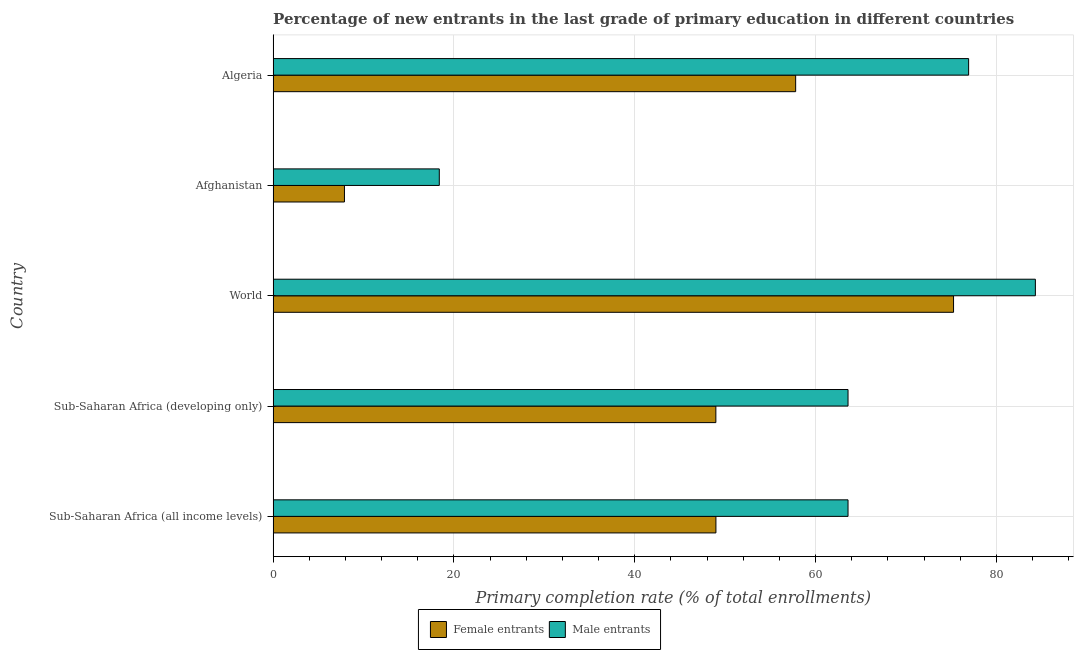How many groups of bars are there?
Offer a very short reply. 5. Are the number of bars on each tick of the Y-axis equal?
Offer a terse response. Yes. How many bars are there on the 3rd tick from the top?
Offer a terse response. 2. What is the label of the 1st group of bars from the top?
Your response must be concise. Algeria. In how many cases, is the number of bars for a given country not equal to the number of legend labels?
Offer a terse response. 0. What is the primary completion rate of female entrants in Algeria?
Offer a very short reply. 57.79. Across all countries, what is the maximum primary completion rate of male entrants?
Keep it short and to the point. 84.3. Across all countries, what is the minimum primary completion rate of female entrants?
Provide a short and direct response. 7.89. In which country was the primary completion rate of male entrants minimum?
Keep it short and to the point. Afghanistan. What is the total primary completion rate of male entrants in the graph?
Make the answer very short. 306.77. What is the difference between the primary completion rate of male entrants in Afghanistan and that in Sub-Saharan Africa (developing only)?
Your answer should be very brief. -45.2. What is the difference between the primary completion rate of female entrants in World and the primary completion rate of male entrants in Afghanistan?
Keep it short and to the point. 56.87. What is the average primary completion rate of female entrants per country?
Your answer should be compact. 47.77. What is the difference between the primary completion rate of male entrants and primary completion rate of female entrants in World?
Make the answer very short. 9.05. In how many countries, is the primary completion rate of male entrants greater than 60 %?
Offer a very short reply. 4. What is the ratio of the primary completion rate of female entrants in Algeria to that in Sub-Saharan Africa (developing only)?
Offer a very short reply. 1.18. What is the difference between the highest and the second highest primary completion rate of female entrants?
Your response must be concise. 17.46. What is the difference between the highest and the lowest primary completion rate of male entrants?
Give a very brief answer. 65.92. In how many countries, is the primary completion rate of male entrants greater than the average primary completion rate of male entrants taken over all countries?
Offer a terse response. 4. What does the 2nd bar from the top in Sub-Saharan Africa (all income levels) represents?
Ensure brevity in your answer.  Female entrants. What does the 1st bar from the bottom in Afghanistan represents?
Give a very brief answer. Female entrants. How many bars are there?
Provide a short and direct response. 10. What is the difference between two consecutive major ticks on the X-axis?
Your answer should be very brief. 20. Does the graph contain grids?
Offer a terse response. Yes. How are the legend labels stacked?
Your response must be concise. Horizontal. What is the title of the graph?
Give a very brief answer. Percentage of new entrants in the last grade of primary education in different countries. What is the label or title of the X-axis?
Give a very brief answer. Primary completion rate (% of total enrollments). What is the Primary completion rate (% of total enrollments) of Female entrants in Sub-Saharan Africa (all income levels)?
Your answer should be very brief. 48.97. What is the Primary completion rate (% of total enrollments) of Male entrants in Sub-Saharan Africa (all income levels)?
Offer a very short reply. 63.58. What is the Primary completion rate (% of total enrollments) in Female entrants in Sub-Saharan Africa (developing only)?
Ensure brevity in your answer.  48.96. What is the Primary completion rate (% of total enrollments) of Male entrants in Sub-Saharan Africa (developing only)?
Offer a very short reply. 63.58. What is the Primary completion rate (% of total enrollments) of Female entrants in World?
Offer a terse response. 75.25. What is the Primary completion rate (% of total enrollments) in Male entrants in World?
Offer a terse response. 84.3. What is the Primary completion rate (% of total enrollments) of Female entrants in Afghanistan?
Your answer should be compact. 7.89. What is the Primary completion rate (% of total enrollments) in Male entrants in Afghanistan?
Your answer should be very brief. 18.38. What is the Primary completion rate (% of total enrollments) in Female entrants in Algeria?
Give a very brief answer. 57.79. What is the Primary completion rate (% of total enrollments) of Male entrants in Algeria?
Give a very brief answer. 76.92. Across all countries, what is the maximum Primary completion rate (% of total enrollments) of Female entrants?
Keep it short and to the point. 75.25. Across all countries, what is the maximum Primary completion rate (% of total enrollments) in Male entrants?
Give a very brief answer. 84.3. Across all countries, what is the minimum Primary completion rate (% of total enrollments) in Female entrants?
Ensure brevity in your answer.  7.89. Across all countries, what is the minimum Primary completion rate (% of total enrollments) of Male entrants?
Offer a terse response. 18.38. What is the total Primary completion rate (% of total enrollments) of Female entrants in the graph?
Your answer should be very brief. 238.87. What is the total Primary completion rate (% of total enrollments) in Male entrants in the graph?
Offer a terse response. 306.77. What is the difference between the Primary completion rate (% of total enrollments) of Female entrants in Sub-Saharan Africa (all income levels) and that in Sub-Saharan Africa (developing only)?
Your response must be concise. 0.01. What is the difference between the Primary completion rate (% of total enrollments) in Male entrants in Sub-Saharan Africa (all income levels) and that in Sub-Saharan Africa (developing only)?
Offer a terse response. 0. What is the difference between the Primary completion rate (% of total enrollments) of Female entrants in Sub-Saharan Africa (all income levels) and that in World?
Your answer should be very brief. -26.28. What is the difference between the Primary completion rate (% of total enrollments) of Male entrants in Sub-Saharan Africa (all income levels) and that in World?
Your answer should be very brief. -20.72. What is the difference between the Primary completion rate (% of total enrollments) in Female entrants in Sub-Saharan Africa (all income levels) and that in Afghanistan?
Keep it short and to the point. 41.08. What is the difference between the Primary completion rate (% of total enrollments) of Male entrants in Sub-Saharan Africa (all income levels) and that in Afghanistan?
Your answer should be very brief. 45.2. What is the difference between the Primary completion rate (% of total enrollments) in Female entrants in Sub-Saharan Africa (all income levels) and that in Algeria?
Provide a succinct answer. -8.82. What is the difference between the Primary completion rate (% of total enrollments) in Male entrants in Sub-Saharan Africa (all income levels) and that in Algeria?
Offer a terse response. -13.34. What is the difference between the Primary completion rate (% of total enrollments) of Female entrants in Sub-Saharan Africa (developing only) and that in World?
Offer a terse response. -26.29. What is the difference between the Primary completion rate (% of total enrollments) in Male entrants in Sub-Saharan Africa (developing only) and that in World?
Ensure brevity in your answer.  -20.72. What is the difference between the Primary completion rate (% of total enrollments) in Female entrants in Sub-Saharan Africa (developing only) and that in Afghanistan?
Offer a very short reply. 41.08. What is the difference between the Primary completion rate (% of total enrollments) in Male entrants in Sub-Saharan Africa (developing only) and that in Afghanistan?
Provide a short and direct response. 45.2. What is the difference between the Primary completion rate (% of total enrollments) of Female entrants in Sub-Saharan Africa (developing only) and that in Algeria?
Ensure brevity in your answer.  -8.83. What is the difference between the Primary completion rate (% of total enrollments) of Male entrants in Sub-Saharan Africa (developing only) and that in Algeria?
Keep it short and to the point. -13.34. What is the difference between the Primary completion rate (% of total enrollments) in Female entrants in World and that in Afghanistan?
Give a very brief answer. 67.36. What is the difference between the Primary completion rate (% of total enrollments) in Male entrants in World and that in Afghanistan?
Offer a terse response. 65.92. What is the difference between the Primary completion rate (% of total enrollments) in Female entrants in World and that in Algeria?
Provide a short and direct response. 17.46. What is the difference between the Primary completion rate (% of total enrollments) in Male entrants in World and that in Algeria?
Offer a terse response. 7.38. What is the difference between the Primary completion rate (% of total enrollments) in Female entrants in Afghanistan and that in Algeria?
Your response must be concise. -49.9. What is the difference between the Primary completion rate (% of total enrollments) in Male entrants in Afghanistan and that in Algeria?
Make the answer very short. -58.54. What is the difference between the Primary completion rate (% of total enrollments) of Female entrants in Sub-Saharan Africa (all income levels) and the Primary completion rate (% of total enrollments) of Male entrants in Sub-Saharan Africa (developing only)?
Ensure brevity in your answer.  -14.61. What is the difference between the Primary completion rate (% of total enrollments) in Female entrants in Sub-Saharan Africa (all income levels) and the Primary completion rate (% of total enrollments) in Male entrants in World?
Your answer should be very brief. -35.33. What is the difference between the Primary completion rate (% of total enrollments) of Female entrants in Sub-Saharan Africa (all income levels) and the Primary completion rate (% of total enrollments) of Male entrants in Afghanistan?
Provide a succinct answer. 30.59. What is the difference between the Primary completion rate (% of total enrollments) of Female entrants in Sub-Saharan Africa (all income levels) and the Primary completion rate (% of total enrollments) of Male entrants in Algeria?
Ensure brevity in your answer.  -27.95. What is the difference between the Primary completion rate (% of total enrollments) of Female entrants in Sub-Saharan Africa (developing only) and the Primary completion rate (% of total enrollments) of Male entrants in World?
Give a very brief answer. -35.34. What is the difference between the Primary completion rate (% of total enrollments) of Female entrants in Sub-Saharan Africa (developing only) and the Primary completion rate (% of total enrollments) of Male entrants in Afghanistan?
Your answer should be compact. 30.59. What is the difference between the Primary completion rate (% of total enrollments) of Female entrants in Sub-Saharan Africa (developing only) and the Primary completion rate (% of total enrollments) of Male entrants in Algeria?
Your answer should be compact. -27.96. What is the difference between the Primary completion rate (% of total enrollments) in Female entrants in World and the Primary completion rate (% of total enrollments) in Male entrants in Afghanistan?
Provide a succinct answer. 56.87. What is the difference between the Primary completion rate (% of total enrollments) of Female entrants in World and the Primary completion rate (% of total enrollments) of Male entrants in Algeria?
Give a very brief answer. -1.67. What is the difference between the Primary completion rate (% of total enrollments) of Female entrants in Afghanistan and the Primary completion rate (% of total enrollments) of Male entrants in Algeria?
Offer a very short reply. -69.03. What is the average Primary completion rate (% of total enrollments) of Female entrants per country?
Offer a very short reply. 47.77. What is the average Primary completion rate (% of total enrollments) in Male entrants per country?
Your answer should be very brief. 61.35. What is the difference between the Primary completion rate (% of total enrollments) of Female entrants and Primary completion rate (% of total enrollments) of Male entrants in Sub-Saharan Africa (all income levels)?
Your response must be concise. -14.61. What is the difference between the Primary completion rate (% of total enrollments) in Female entrants and Primary completion rate (% of total enrollments) in Male entrants in Sub-Saharan Africa (developing only)?
Provide a succinct answer. -14.62. What is the difference between the Primary completion rate (% of total enrollments) in Female entrants and Primary completion rate (% of total enrollments) in Male entrants in World?
Offer a very short reply. -9.05. What is the difference between the Primary completion rate (% of total enrollments) of Female entrants and Primary completion rate (% of total enrollments) of Male entrants in Afghanistan?
Your answer should be compact. -10.49. What is the difference between the Primary completion rate (% of total enrollments) in Female entrants and Primary completion rate (% of total enrollments) in Male entrants in Algeria?
Your answer should be compact. -19.13. What is the ratio of the Primary completion rate (% of total enrollments) in Female entrants in Sub-Saharan Africa (all income levels) to that in World?
Offer a very short reply. 0.65. What is the ratio of the Primary completion rate (% of total enrollments) in Male entrants in Sub-Saharan Africa (all income levels) to that in World?
Your response must be concise. 0.75. What is the ratio of the Primary completion rate (% of total enrollments) in Female entrants in Sub-Saharan Africa (all income levels) to that in Afghanistan?
Your answer should be compact. 6.21. What is the ratio of the Primary completion rate (% of total enrollments) of Male entrants in Sub-Saharan Africa (all income levels) to that in Afghanistan?
Keep it short and to the point. 3.46. What is the ratio of the Primary completion rate (% of total enrollments) in Female entrants in Sub-Saharan Africa (all income levels) to that in Algeria?
Provide a succinct answer. 0.85. What is the ratio of the Primary completion rate (% of total enrollments) of Male entrants in Sub-Saharan Africa (all income levels) to that in Algeria?
Make the answer very short. 0.83. What is the ratio of the Primary completion rate (% of total enrollments) in Female entrants in Sub-Saharan Africa (developing only) to that in World?
Offer a very short reply. 0.65. What is the ratio of the Primary completion rate (% of total enrollments) in Male entrants in Sub-Saharan Africa (developing only) to that in World?
Provide a succinct answer. 0.75. What is the ratio of the Primary completion rate (% of total enrollments) in Female entrants in Sub-Saharan Africa (developing only) to that in Afghanistan?
Your answer should be very brief. 6.21. What is the ratio of the Primary completion rate (% of total enrollments) in Male entrants in Sub-Saharan Africa (developing only) to that in Afghanistan?
Your response must be concise. 3.46. What is the ratio of the Primary completion rate (% of total enrollments) of Female entrants in Sub-Saharan Africa (developing only) to that in Algeria?
Give a very brief answer. 0.85. What is the ratio of the Primary completion rate (% of total enrollments) in Male entrants in Sub-Saharan Africa (developing only) to that in Algeria?
Give a very brief answer. 0.83. What is the ratio of the Primary completion rate (% of total enrollments) of Female entrants in World to that in Afghanistan?
Provide a succinct answer. 9.54. What is the ratio of the Primary completion rate (% of total enrollments) of Male entrants in World to that in Afghanistan?
Your answer should be very brief. 4.59. What is the ratio of the Primary completion rate (% of total enrollments) of Female entrants in World to that in Algeria?
Offer a very short reply. 1.3. What is the ratio of the Primary completion rate (% of total enrollments) in Male entrants in World to that in Algeria?
Ensure brevity in your answer.  1.1. What is the ratio of the Primary completion rate (% of total enrollments) of Female entrants in Afghanistan to that in Algeria?
Provide a short and direct response. 0.14. What is the ratio of the Primary completion rate (% of total enrollments) in Male entrants in Afghanistan to that in Algeria?
Your answer should be compact. 0.24. What is the difference between the highest and the second highest Primary completion rate (% of total enrollments) in Female entrants?
Keep it short and to the point. 17.46. What is the difference between the highest and the second highest Primary completion rate (% of total enrollments) of Male entrants?
Offer a terse response. 7.38. What is the difference between the highest and the lowest Primary completion rate (% of total enrollments) in Female entrants?
Your response must be concise. 67.36. What is the difference between the highest and the lowest Primary completion rate (% of total enrollments) in Male entrants?
Ensure brevity in your answer.  65.92. 